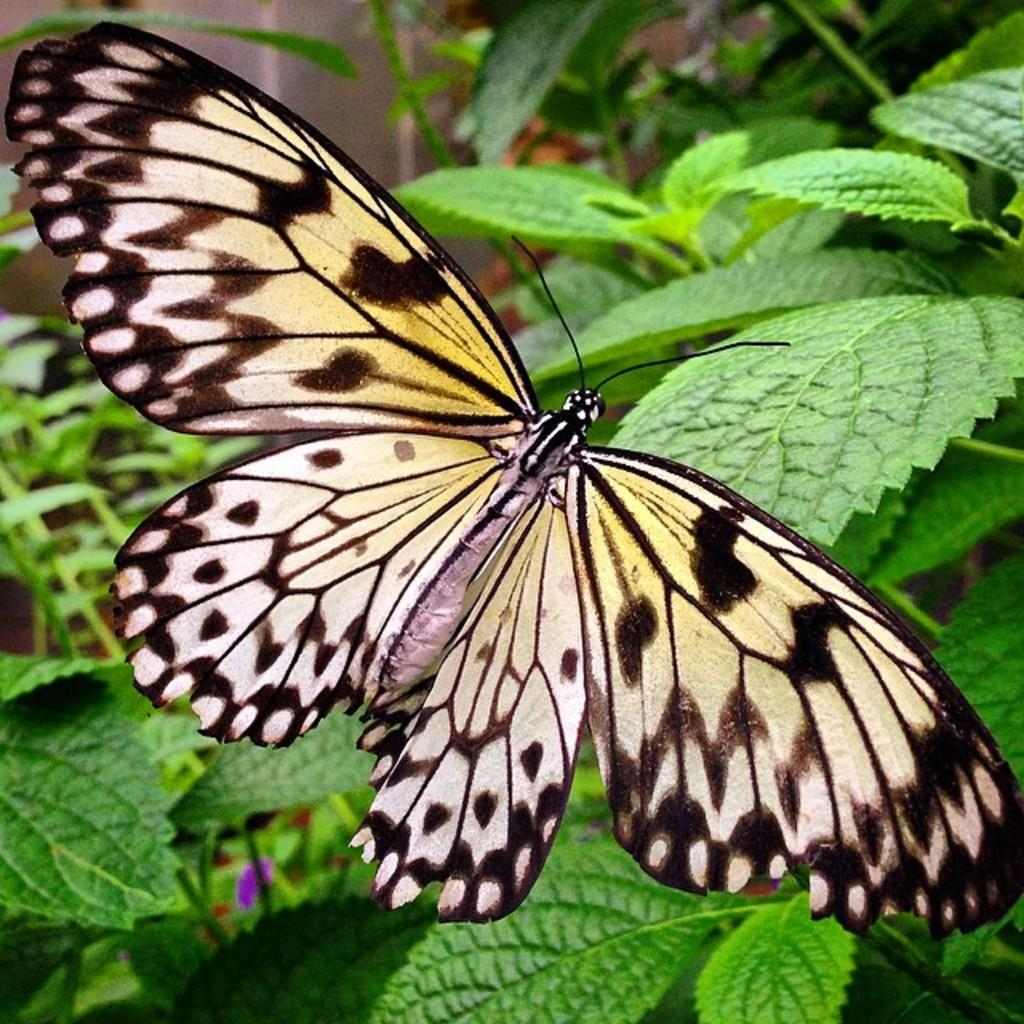What type of insect is present in the image? There is a yellow and black butterfly in the image. What can be seen in the background of the image? There are green leaves in the background of the image. How would you describe the quality of the image? The image is slightly blurry in the background. How many geese are visible in the image? There are no geese present in the image; it features a yellow and black butterfly and green leaves in the background. What type of toy can be seen in the image? There is no toy present in the image. 